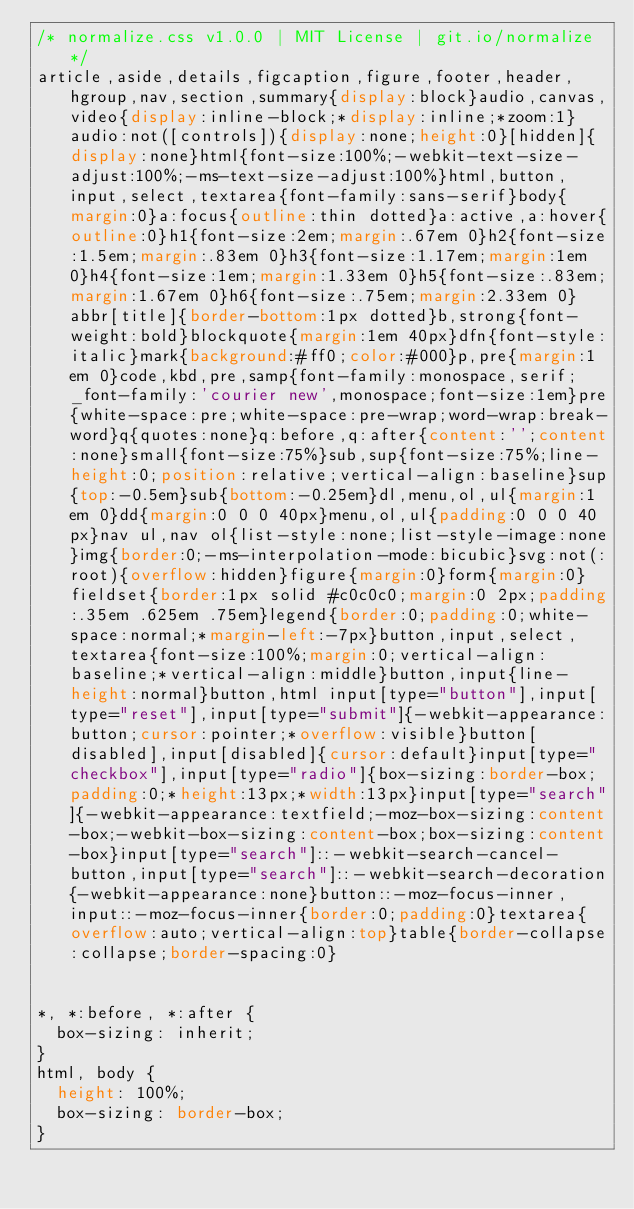Convert code to text. <code><loc_0><loc_0><loc_500><loc_500><_CSS_>/* normalize.css v1.0.0 | MIT License | git.io/normalize */
article,aside,details,figcaption,figure,footer,header,hgroup,nav,section,summary{display:block}audio,canvas,video{display:inline-block;*display:inline;*zoom:1}audio:not([controls]){display:none;height:0}[hidden]{display:none}html{font-size:100%;-webkit-text-size-adjust:100%;-ms-text-size-adjust:100%}html,button,input,select,textarea{font-family:sans-serif}body{margin:0}a:focus{outline:thin dotted}a:active,a:hover{outline:0}h1{font-size:2em;margin:.67em 0}h2{font-size:1.5em;margin:.83em 0}h3{font-size:1.17em;margin:1em 0}h4{font-size:1em;margin:1.33em 0}h5{font-size:.83em;margin:1.67em 0}h6{font-size:.75em;margin:2.33em 0}abbr[title]{border-bottom:1px dotted}b,strong{font-weight:bold}blockquote{margin:1em 40px}dfn{font-style:italic}mark{background:#ff0;color:#000}p,pre{margin:1em 0}code,kbd,pre,samp{font-family:monospace,serif;_font-family:'courier new',monospace;font-size:1em}pre{white-space:pre;white-space:pre-wrap;word-wrap:break-word}q{quotes:none}q:before,q:after{content:'';content:none}small{font-size:75%}sub,sup{font-size:75%;line-height:0;position:relative;vertical-align:baseline}sup{top:-0.5em}sub{bottom:-0.25em}dl,menu,ol,ul{margin:1em 0}dd{margin:0 0 0 40px}menu,ol,ul{padding:0 0 0 40px}nav ul,nav ol{list-style:none;list-style-image:none}img{border:0;-ms-interpolation-mode:bicubic}svg:not(:root){overflow:hidden}figure{margin:0}form{margin:0}fieldset{border:1px solid #c0c0c0;margin:0 2px;padding:.35em .625em .75em}legend{border:0;padding:0;white-space:normal;*margin-left:-7px}button,input,select,textarea{font-size:100%;margin:0;vertical-align:baseline;*vertical-align:middle}button,input{line-height:normal}button,html input[type="button"],input[type="reset"],input[type="submit"]{-webkit-appearance:button;cursor:pointer;*overflow:visible}button[disabled],input[disabled]{cursor:default}input[type="checkbox"],input[type="radio"]{box-sizing:border-box;padding:0;*height:13px;*width:13px}input[type="search"]{-webkit-appearance:textfield;-moz-box-sizing:content-box;-webkit-box-sizing:content-box;box-sizing:content-box}input[type="search"]::-webkit-search-cancel-button,input[type="search"]::-webkit-search-decoration{-webkit-appearance:none}button::-moz-focus-inner,input::-moz-focus-inner{border:0;padding:0}textarea{overflow:auto;vertical-align:top}table{border-collapse:collapse;border-spacing:0}


*, *:before, *:after {
  box-sizing: inherit;
}
html, body {
  height: 100%;
  box-sizing: border-box;
}</code> 